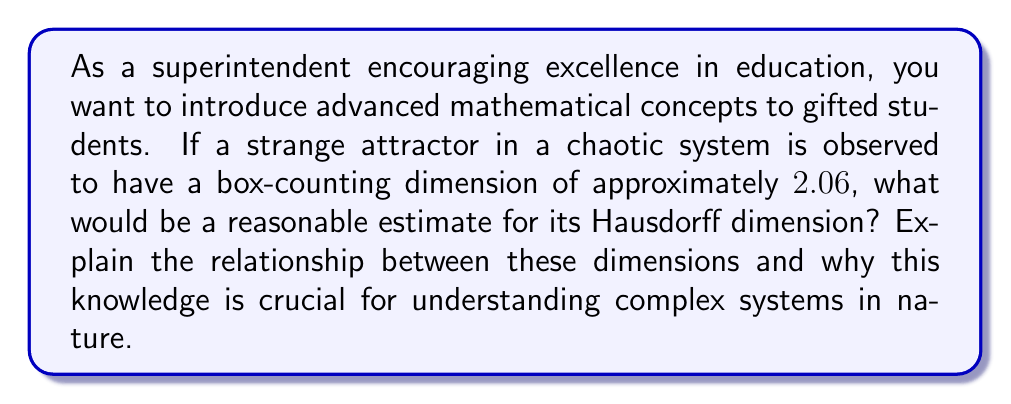Provide a solution to this math problem. To answer this question, let's break it down into steps:

1. Understand the relationship between box-counting dimension and Hausdorff dimension:
   The box-counting dimension, also known as the Minkowski–Bouligand dimension, is often easier to calculate and approximates the Hausdorff dimension. For most well-behaved fractals, these dimensions are equal. However, the Hausdorff dimension is always less than or equal to the box-counting dimension.

   $$D_H \leq D_B$$

   Where $D_H$ is the Hausdorff dimension and $D_B$ is the box-counting dimension.

2. Interpret the given box-counting dimension:
   We are given that the box-counting dimension is approximately 2.06.

   $$D_B \approx 2.06$$

3. Estimate the Hausdorff dimension:
   Given that the Hausdorff dimension is typically very close to (and often equal to) the box-counting dimension for strange attractors, we can estimate that the Hausdorff dimension is also approximately 2.06.

   $$D_H \approx 2.06$$

4. Understand the significance:
   - A non-integer dimension (between 2 and 3) indicates that the attractor has a fractal structure.
   - This fractional dimension suggests that the attractor has more complexity than a 2D object but doesn't fully fill 3D space.
   - The fractional nature of the dimension is a key characteristic of strange attractors and chaotic systems.

5. Importance in understanding complex systems:
   - Fractal dimensions provide a quantitative measure of the complexity and self-similarity in chaotic systems.
   - They help in classifying different types of attractors and understanding the underlying dynamics of the system.
   - In nature, many systems exhibit fractal-like behavior (e.g., coastlines, trees, blood vessels), and understanding fractal dimensions aids in modeling and analyzing these complex natural phenomena.
Answer: $D_H \approx 2.06$ 